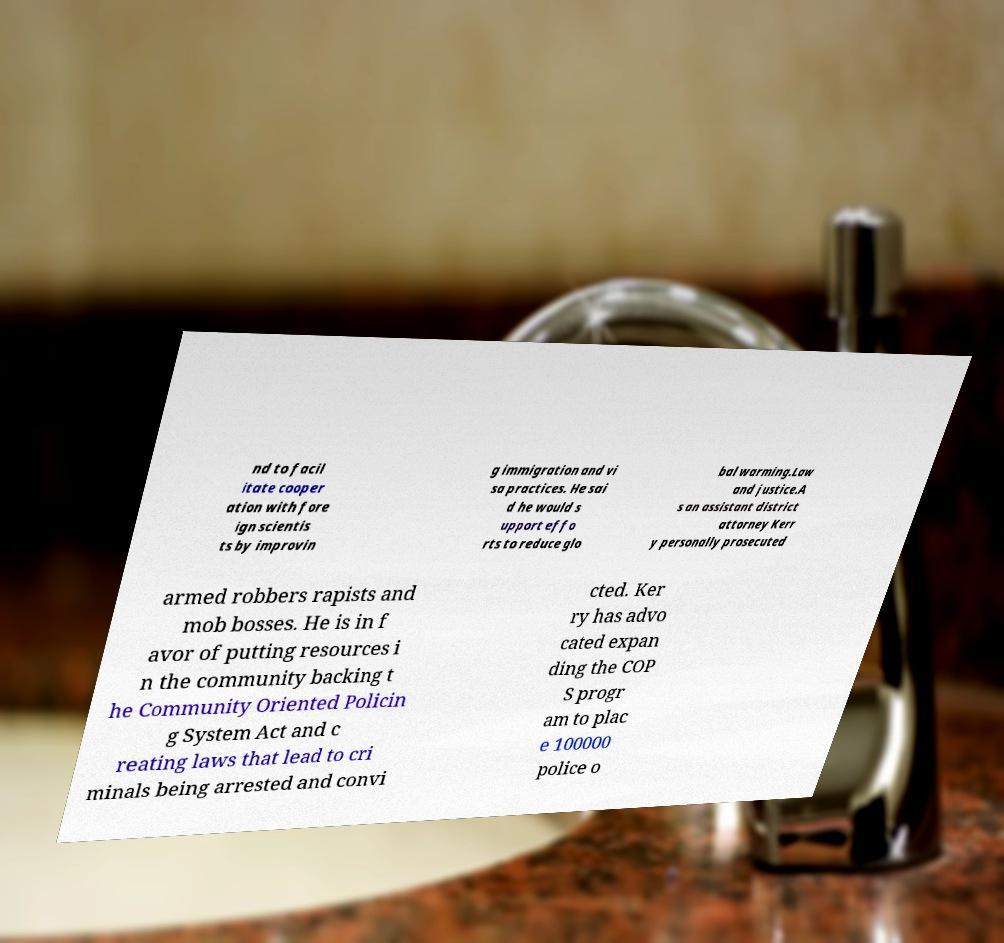Please read and relay the text visible in this image. What does it say? nd to facil itate cooper ation with fore ign scientis ts by improvin g immigration and vi sa practices. He sai d he would s upport effo rts to reduce glo bal warming.Law and justice.A s an assistant district attorney Kerr y personally prosecuted armed robbers rapists and mob bosses. He is in f avor of putting resources i n the community backing t he Community Oriented Policin g System Act and c reating laws that lead to cri minals being arrested and convi cted. Ker ry has advo cated expan ding the COP S progr am to plac e 100000 police o 